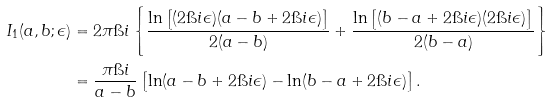<formula> <loc_0><loc_0><loc_500><loc_500>I _ { 1 } ( a , b ; \epsilon ) & = 2 \pi \i i \left \{ \frac { \ln \left [ ( 2 \i i \epsilon ) ( a - b + 2 \i i \epsilon ) \right ] } { 2 ( a - b ) } + \frac { \ln \left [ ( b - a + 2 \i i \epsilon ) ( 2 \i i \epsilon ) \right ] } { 2 ( b - a ) } \right \} \\ & = \frac { \pi \i i } { a - b } \left [ \ln ( a - b + 2 \i i \epsilon ) - \ln ( b - a + 2 \i i \epsilon ) \right ] .</formula> 